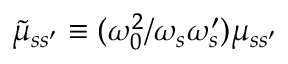<formula> <loc_0><loc_0><loc_500><loc_500>\tilde { \mu } _ { s s ^ { \prime } } \equiv ( \omega _ { 0 } ^ { 2 } / \omega _ { s } \omega _ { s } ^ { \prime } ) \mu _ { s s ^ { \prime } }</formula> 